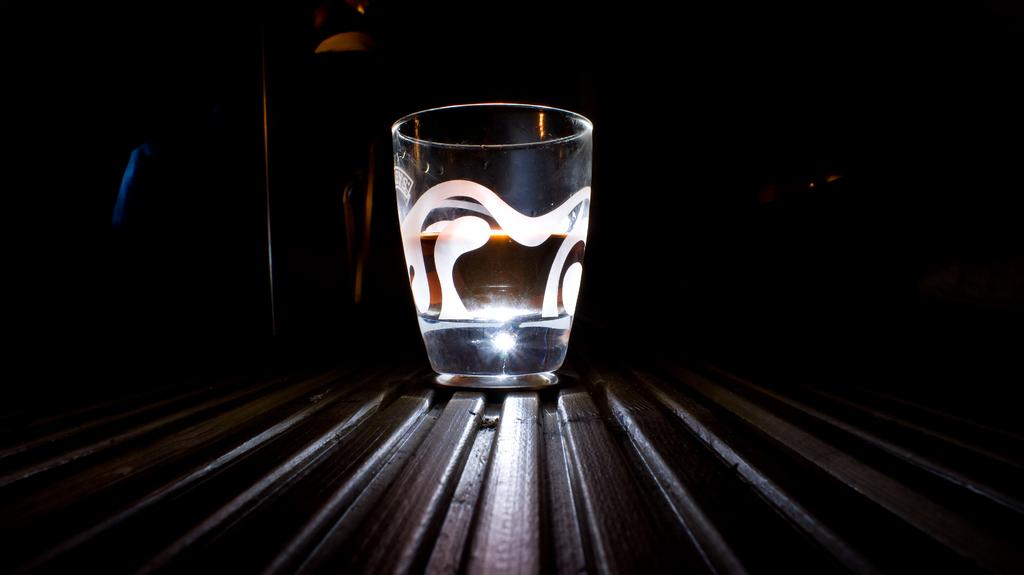What object is visible in the image? There is a glass in the image. Where is the glass located? The glass is on a surface. Can you describe the background of the image? The background of the image is dark. What type of cord is connected to the glass in the image? There is no cord connected to the glass in the image. What is the glass made of, specifically mentioning the element zinc? The glass is not made of zinc, and there is no mention of any specific elements in the image. 